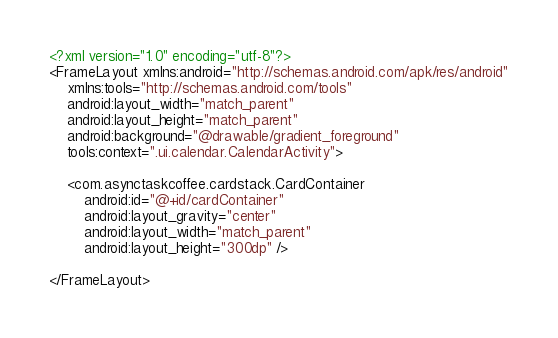<code> <loc_0><loc_0><loc_500><loc_500><_XML_><?xml version="1.0" encoding="utf-8"?>
<FrameLayout xmlns:android="http://schemas.android.com/apk/res/android"
    xmlns:tools="http://schemas.android.com/tools"
    android:layout_width="match_parent"
    android:layout_height="match_parent"
    android:background="@drawable/gradient_foreground"
    tools:context=".ui.calendar.CalendarActivity">

    <com.asynctaskcoffee.cardstack.CardContainer
        android:id="@+id/cardContainer"
        android:layout_gravity="center"
        android:layout_width="match_parent"
        android:layout_height="300dp" />

</FrameLayout></code> 